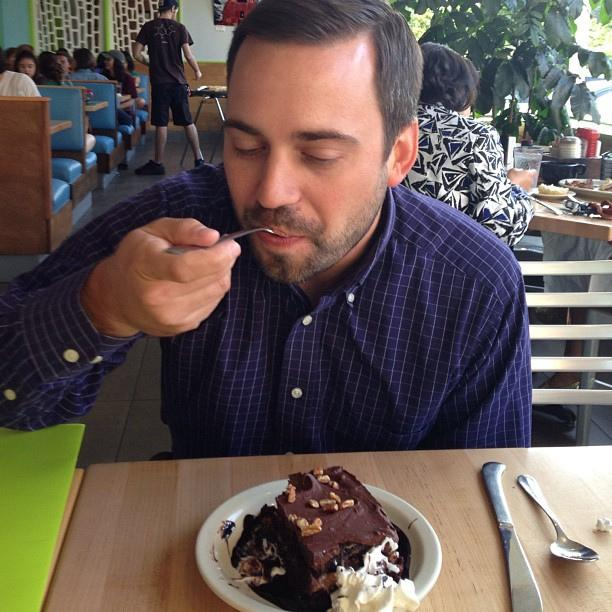What type of restaurant is this? Please explain your reasoning. diner. These people are eating deserts from a diner. 